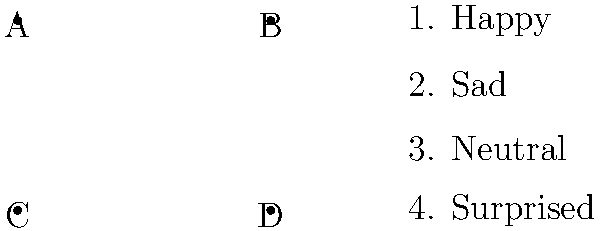Match the facial expressions (A-D) with the corresponding emotions (1-4) for patients with right hemisphere damage. Which combination is correct? To answer this question, we need to understand the relationship between facial expressions and emotions, particularly in the context of patients with right hemisphere damage. Let's analyze each step:

1. Understand right hemisphere damage:
   - The right hemisphere plays a crucial role in processing emotions and facial expressions.
   - Patients with right hemisphere damage often have difficulty recognizing and interpreting facial expressions.

2. Analyze the facial expressions in the image:
   A. Upward curved mouth (smile) - typically associated with happiness
   B. Downward curved mouth (frown) - typically associated with sadness
   C. Straight line mouth - typically associated with a neutral expression
   D. Open mouth with raised eyebrows - typically associated with surprise

3. Match the expressions to the emotions:
   1. Happy - matches with A (smile)
   2. Sad - matches with B (frown)
   3. Neutral - matches with C (straight line)
   4. Surprised - matches with D (open mouth)

4. Consider the impact of right hemisphere damage:
   - Patients may have difficulty distinguishing between subtle expressions.
   - However, the given expressions are distinct enough that even with impairment, they should be recognizable.

5. Determine the correct combination:
   The correct matching is A-1, B-2, C-3, D-4.

Therefore, the combination that correctly matches facial expressions to emotions is A-1, B-2, C-3, D-4.
Answer: A-1, B-2, C-3, D-4 